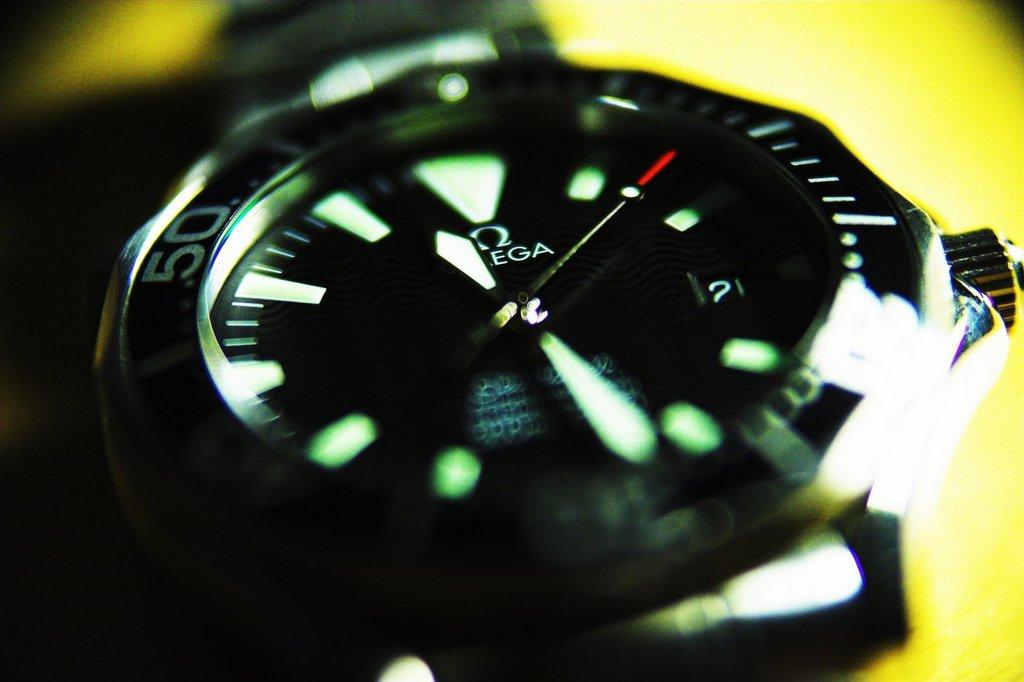Provide a one-sentence caption for the provided image. close up or omega wristwatch on a yellow background. 